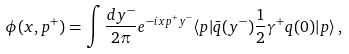<formula> <loc_0><loc_0><loc_500><loc_500>\phi ( x , p ^ { + } ) = \int \frac { d y ^ { - } } { 2 \pi } e ^ { - i x p ^ { + } y ^ { - } } \langle p | { \bar { q } } ( y ^ { - } ) \frac { 1 } { 2 } \gamma ^ { + } q ( 0 ) | p \rangle \, ,</formula> 